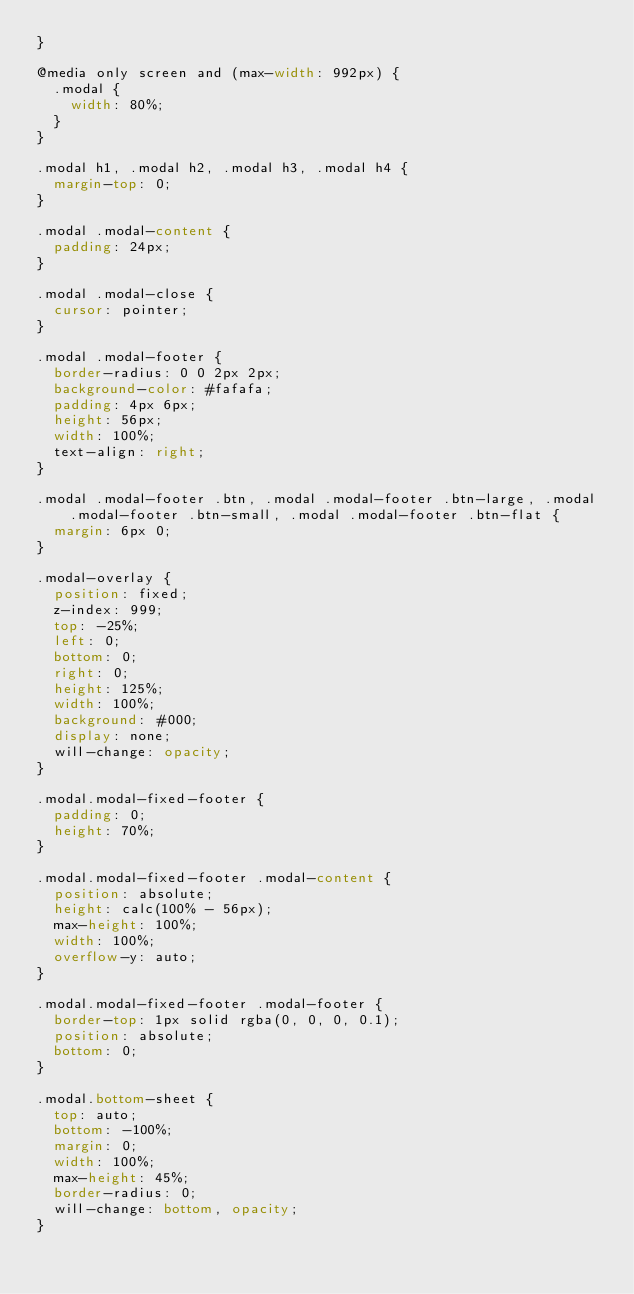<code> <loc_0><loc_0><loc_500><loc_500><_CSS_>}

@media only screen and (max-width: 992px) {
  .modal {
    width: 80%;
  }
}

.modal h1, .modal h2, .modal h3, .modal h4 {
  margin-top: 0;
}

.modal .modal-content {
  padding: 24px;
}

.modal .modal-close {
  cursor: pointer;
}

.modal .modal-footer {
  border-radius: 0 0 2px 2px;
  background-color: #fafafa;
  padding: 4px 6px;
  height: 56px;
  width: 100%;
  text-align: right;
}

.modal .modal-footer .btn, .modal .modal-footer .btn-large, .modal .modal-footer .btn-small, .modal .modal-footer .btn-flat {
  margin: 6px 0;
}

.modal-overlay {
  position: fixed;
  z-index: 999;
  top: -25%;
  left: 0;
  bottom: 0;
  right: 0;
  height: 125%;
  width: 100%;
  background: #000;
  display: none;
  will-change: opacity;
}

.modal.modal-fixed-footer {
  padding: 0;
  height: 70%;
}

.modal.modal-fixed-footer .modal-content {
  position: absolute;
  height: calc(100% - 56px);
  max-height: 100%;
  width: 100%;
  overflow-y: auto;
}

.modal.modal-fixed-footer .modal-footer {
  border-top: 1px solid rgba(0, 0, 0, 0.1);
  position: absolute;
  bottom: 0;
}

.modal.bottom-sheet {
  top: auto;
  bottom: -100%;
  margin: 0;
  width: 100%;
  max-height: 45%;
  border-radius: 0;
  will-change: bottom, opacity;
}</code> 